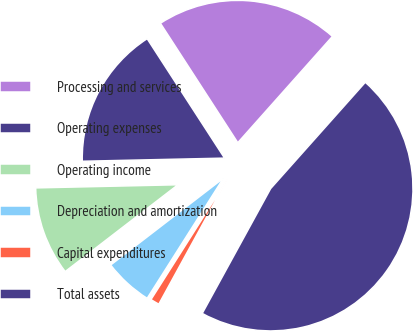<chart> <loc_0><loc_0><loc_500><loc_500><pie_chart><fcel>Processing and services<fcel>Operating expenses<fcel>Operating income<fcel>Depreciation and amortization<fcel>Capital expenditures<fcel>Total assets<nl><fcel>20.73%<fcel>16.2%<fcel>10.09%<fcel>5.56%<fcel>1.02%<fcel>46.4%<nl></chart> 